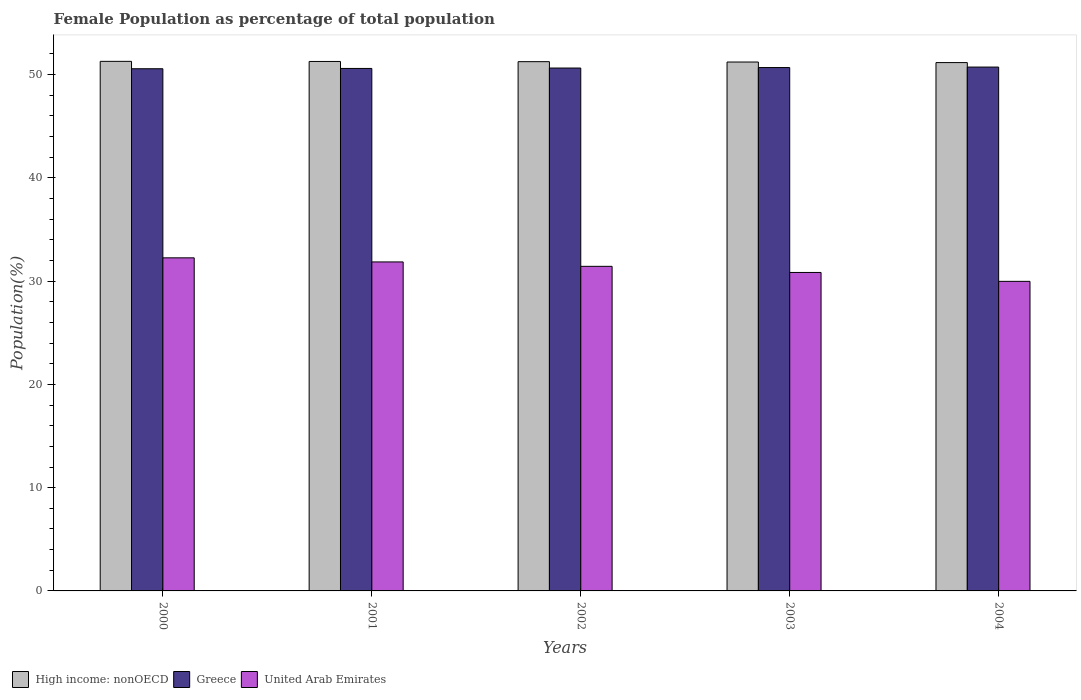Are the number of bars on each tick of the X-axis equal?
Your answer should be very brief. Yes. What is the label of the 4th group of bars from the left?
Ensure brevity in your answer.  2003. What is the female population in in High income: nonOECD in 2002?
Your answer should be very brief. 51.25. Across all years, what is the maximum female population in in United Arab Emirates?
Make the answer very short. 32.26. Across all years, what is the minimum female population in in High income: nonOECD?
Provide a succinct answer. 51.16. In which year was the female population in in High income: nonOECD minimum?
Offer a terse response. 2004. What is the total female population in in High income: nonOECD in the graph?
Your answer should be very brief. 256.2. What is the difference between the female population in in United Arab Emirates in 2000 and that in 2003?
Offer a very short reply. 1.42. What is the difference between the female population in in United Arab Emirates in 2000 and the female population in in High income: nonOECD in 2004?
Your answer should be compact. -18.91. What is the average female population in in High income: nonOECD per year?
Provide a succinct answer. 51.24. In the year 2003, what is the difference between the female population in in Greece and female population in in United Arab Emirates?
Give a very brief answer. 19.84. In how many years, is the female population in in Greece greater than 18 %?
Ensure brevity in your answer.  5. What is the ratio of the female population in in United Arab Emirates in 2000 to that in 2002?
Ensure brevity in your answer.  1.03. Is the difference between the female population in in Greece in 2000 and 2003 greater than the difference between the female population in in United Arab Emirates in 2000 and 2003?
Your answer should be compact. No. What is the difference between the highest and the second highest female population in in Greece?
Make the answer very short. 0.05. What is the difference between the highest and the lowest female population in in United Arab Emirates?
Your answer should be very brief. 2.28. In how many years, is the female population in in United Arab Emirates greater than the average female population in in United Arab Emirates taken over all years?
Ensure brevity in your answer.  3. Is the sum of the female population in in United Arab Emirates in 2000 and 2001 greater than the maximum female population in in Greece across all years?
Ensure brevity in your answer.  Yes. What does the 1st bar from the left in 2002 represents?
Keep it short and to the point. High income: nonOECD. What does the 2nd bar from the right in 2001 represents?
Give a very brief answer. Greece. Is it the case that in every year, the sum of the female population in in United Arab Emirates and female population in in Greece is greater than the female population in in High income: nonOECD?
Provide a short and direct response. Yes. Are all the bars in the graph horizontal?
Ensure brevity in your answer.  No. How many years are there in the graph?
Provide a succinct answer. 5. What is the difference between two consecutive major ticks on the Y-axis?
Give a very brief answer. 10. Does the graph contain any zero values?
Provide a short and direct response. No. Where does the legend appear in the graph?
Keep it short and to the point. Bottom left. How are the legend labels stacked?
Make the answer very short. Horizontal. What is the title of the graph?
Provide a succinct answer. Female Population as percentage of total population. What is the label or title of the Y-axis?
Your response must be concise. Population(%). What is the Population(%) of High income: nonOECD in 2000?
Ensure brevity in your answer.  51.28. What is the Population(%) in Greece in 2000?
Keep it short and to the point. 50.57. What is the Population(%) of United Arab Emirates in 2000?
Ensure brevity in your answer.  32.26. What is the Population(%) in High income: nonOECD in 2001?
Offer a terse response. 51.27. What is the Population(%) of Greece in 2001?
Make the answer very short. 50.6. What is the Population(%) of United Arab Emirates in 2001?
Provide a short and direct response. 31.86. What is the Population(%) of High income: nonOECD in 2002?
Provide a short and direct response. 51.25. What is the Population(%) in Greece in 2002?
Your answer should be compact. 50.64. What is the Population(%) in United Arab Emirates in 2002?
Ensure brevity in your answer.  31.43. What is the Population(%) of High income: nonOECD in 2003?
Your answer should be compact. 51.22. What is the Population(%) of Greece in 2003?
Offer a terse response. 50.68. What is the Population(%) of United Arab Emirates in 2003?
Offer a terse response. 30.84. What is the Population(%) of High income: nonOECD in 2004?
Your answer should be compact. 51.16. What is the Population(%) in Greece in 2004?
Your answer should be very brief. 50.73. What is the Population(%) of United Arab Emirates in 2004?
Your answer should be very brief. 29.98. Across all years, what is the maximum Population(%) of High income: nonOECD?
Provide a succinct answer. 51.28. Across all years, what is the maximum Population(%) of Greece?
Keep it short and to the point. 50.73. Across all years, what is the maximum Population(%) in United Arab Emirates?
Your answer should be compact. 32.26. Across all years, what is the minimum Population(%) in High income: nonOECD?
Offer a terse response. 51.16. Across all years, what is the minimum Population(%) in Greece?
Offer a very short reply. 50.57. Across all years, what is the minimum Population(%) of United Arab Emirates?
Your answer should be compact. 29.98. What is the total Population(%) in High income: nonOECD in the graph?
Keep it short and to the point. 256.2. What is the total Population(%) in Greece in the graph?
Offer a terse response. 253.22. What is the total Population(%) of United Arab Emirates in the graph?
Offer a very short reply. 156.37. What is the difference between the Population(%) in Greece in 2000 and that in 2001?
Provide a short and direct response. -0.03. What is the difference between the Population(%) in United Arab Emirates in 2000 and that in 2001?
Make the answer very short. 0.4. What is the difference between the Population(%) in High income: nonOECD in 2000 and that in 2002?
Give a very brief answer. 0.03. What is the difference between the Population(%) in Greece in 2000 and that in 2002?
Offer a very short reply. -0.07. What is the difference between the Population(%) of United Arab Emirates in 2000 and that in 2002?
Give a very brief answer. 0.82. What is the difference between the Population(%) of High income: nonOECD in 2000 and that in 2003?
Keep it short and to the point. 0.06. What is the difference between the Population(%) in Greece in 2000 and that in 2003?
Give a very brief answer. -0.12. What is the difference between the Population(%) of United Arab Emirates in 2000 and that in 2003?
Give a very brief answer. 1.42. What is the difference between the Population(%) in High income: nonOECD in 2000 and that in 2004?
Give a very brief answer. 0.12. What is the difference between the Population(%) of Greece in 2000 and that in 2004?
Ensure brevity in your answer.  -0.16. What is the difference between the Population(%) of United Arab Emirates in 2000 and that in 2004?
Your response must be concise. 2.28. What is the difference between the Population(%) of High income: nonOECD in 2001 and that in 2002?
Your response must be concise. 0.02. What is the difference between the Population(%) of Greece in 2001 and that in 2002?
Your answer should be very brief. -0.04. What is the difference between the Population(%) of United Arab Emirates in 2001 and that in 2002?
Ensure brevity in your answer.  0.43. What is the difference between the Population(%) in High income: nonOECD in 2001 and that in 2003?
Your response must be concise. 0.05. What is the difference between the Population(%) of Greece in 2001 and that in 2003?
Make the answer very short. -0.09. What is the difference between the Population(%) of United Arab Emirates in 2001 and that in 2003?
Ensure brevity in your answer.  1.02. What is the difference between the Population(%) in High income: nonOECD in 2001 and that in 2004?
Keep it short and to the point. 0.11. What is the difference between the Population(%) in Greece in 2001 and that in 2004?
Ensure brevity in your answer.  -0.13. What is the difference between the Population(%) of United Arab Emirates in 2001 and that in 2004?
Provide a short and direct response. 1.88. What is the difference between the Population(%) of High income: nonOECD in 2002 and that in 2003?
Give a very brief answer. 0.03. What is the difference between the Population(%) in Greece in 2002 and that in 2003?
Ensure brevity in your answer.  -0.05. What is the difference between the Population(%) in United Arab Emirates in 2002 and that in 2003?
Your answer should be compact. 0.59. What is the difference between the Population(%) in High income: nonOECD in 2002 and that in 2004?
Offer a terse response. 0.09. What is the difference between the Population(%) in Greece in 2002 and that in 2004?
Offer a terse response. -0.09. What is the difference between the Population(%) of United Arab Emirates in 2002 and that in 2004?
Your response must be concise. 1.45. What is the difference between the Population(%) of High income: nonOECD in 2003 and that in 2004?
Make the answer very short. 0.06. What is the difference between the Population(%) of Greece in 2003 and that in 2004?
Your response must be concise. -0.05. What is the difference between the Population(%) of United Arab Emirates in 2003 and that in 2004?
Your response must be concise. 0.86. What is the difference between the Population(%) in High income: nonOECD in 2000 and the Population(%) in Greece in 2001?
Your answer should be very brief. 0.69. What is the difference between the Population(%) of High income: nonOECD in 2000 and the Population(%) of United Arab Emirates in 2001?
Give a very brief answer. 19.42. What is the difference between the Population(%) in Greece in 2000 and the Population(%) in United Arab Emirates in 2001?
Ensure brevity in your answer.  18.71. What is the difference between the Population(%) in High income: nonOECD in 2000 and the Population(%) in Greece in 2002?
Keep it short and to the point. 0.65. What is the difference between the Population(%) in High income: nonOECD in 2000 and the Population(%) in United Arab Emirates in 2002?
Ensure brevity in your answer.  19.85. What is the difference between the Population(%) of Greece in 2000 and the Population(%) of United Arab Emirates in 2002?
Make the answer very short. 19.14. What is the difference between the Population(%) in High income: nonOECD in 2000 and the Population(%) in Greece in 2003?
Make the answer very short. 0.6. What is the difference between the Population(%) in High income: nonOECD in 2000 and the Population(%) in United Arab Emirates in 2003?
Your answer should be compact. 20.44. What is the difference between the Population(%) in Greece in 2000 and the Population(%) in United Arab Emirates in 2003?
Offer a terse response. 19.73. What is the difference between the Population(%) of High income: nonOECD in 2000 and the Population(%) of Greece in 2004?
Your response must be concise. 0.55. What is the difference between the Population(%) in High income: nonOECD in 2000 and the Population(%) in United Arab Emirates in 2004?
Your response must be concise. 21.31. What is the difference between the Population(%) of Greece in 2000 and the Population(%) of United Arab Emirates in 2004?
Provide a short and direct response. 20.59. What is the difference between the Population(%) in High income: nonOECD in 2001 and the Population(%) in Greece in 2002?
Ensure brevity in your answer.  0.64. What is the difference between the Population(%) of High income: nonOECD in 2001 and the Population(%) of United Arab Emirates in 2002?
Your answer should be compact. 19.84. What is the difference between the Population(%) of Greece in 2001 and the Population(%) of United Arab Emirates in 2002?
Keep it short and to the point. 19.16. What is the difference between the Population(%) of High income: nonOECD in 2001 and the Population(%) of Greece in 2003?
Ensure brevity in your answer.  0.59. What is the difference between the Population(%) in High income: nonOECD in 2001 and the Population(%) in United Arab Emirates in 2003?
Make the answer very short. 20.43. What is the difference between the Population(%) in Greece in 2001 and the Population(%) in United Arab Emirates in 2003?
Your response must be concise. 19.76. What is the difference between the Population(%) of High income: nonOECD in 2001 and the Population(%) of Greece in 2004?
Your answer should be very brief. 0.54. What is the difference between the Population(%) in High income: nonOECD in 2001 and the Population(%) in United Arab Emirates in 2004?
Your answer should be compact. 21.3. What is the difference between the Population(%) in Greece in 2001 and the Population(%) in United Arab Emirates in 2004?
Offer a very short reply. 20.62. What is the difference between the Population(%) of High income: nonOECD in 2002 and the Population(%) of Greece in 2003?
Offer a very short reply. 0.57. What is the difference between the Population(%) of High income: nonOECD in 2002 and the Population(%) of United Arab Emirates in 2003?
Provide a succinct answer. 20.42. What is the difference between the Population(%) in Greece in 2002 and the Population(%) in United Arab Emirates in 2003?
Offer a very short reply. 19.8. What is the difference between the Population(%) of High income: nonOECD in 2002 and the Population(%) of Greece in 2004?
Provide a short and direct response. 0.52. What is the difference between the Population(%) in High income: nonOECD in 2002 and the Population(%) in United Arab Emirates in 2004?
Give a very brief answer. 21.28. What is the difference between the Population(%) of Greece in 2002 and the Population(%) of United Arab Emirates in 2004?
Ensure brevity in your answer.  20.66. What is the difference between the Population(%) in High income: nonOECD in 2003 and the Population(%) in Greece in 2004?
Offer a very short reply. 0.49. What is the difference between the Population(%) of High income: nonOECD in 2003 and the Population(%) of United Arab Emirates in 2004?
Your answer should be compact. 21.24. What is the difference between the Population(%) of Greece in 2003 and the Population(%) of United Arab Emirates in 2004?
Give a very brief answer. 20.7. What is the average Population(%) in High income: nonOECD per year?
Your response must be concise. 51.24. What is the average Population(%) in Greece per year?
Your answer should be very brief. 50.64. What is the average Population(%) of United Arab Emirates per year?
Give a very brief answer. 31.27. In the year 2000, what is the difference between the Population(%) of High income: nonOECD and Population(%) of Greece?
Ensure brevity in your answer.  0.72. In the year 2000, what is the difference between the Population(%) in High income: nonOECD and Population(%) in United Arab Emirates?
Ensure brevity in your answer.  19.03. In the year 2000, what is the difference between the Population(%) in Greece and Population(%) in United Arab Emirates?
Give a very brief answer. 18.31. In the year 2001, what is the difference between the Population(%) in High income: nonOECD and Population(%) in Greece?
Keep it short and to the point. 0.68. In the year 2001, what is the difference between the Population(%) in High income: nonOECD and Population(%) in United Arab Emirates?
Offer a very short reply. 19.41. In the year 2001, what is the difference between the Population(%) of Greece and Population(%) of United Arab Emirates?
Offer a very short reply. 18.74. In the year 2002, what is the difference between the Population(%) of High income: nonOECD and Population(%) of Greece?
Provide a succinct answer. 0.62. In the year 2002, what is the difference between the Population(%) of High income: nonOECD and Population(%) of United Arab Emirates?
Your response must be concise. 19.82. In the year 2002, what is the difference between the Population(%) in Greece and Population(%) in United Arab Emirates?
Offer a terse response. 19.2. In the year 2003, what is the difference between the Population(%) in High income: nonOECD and Population(%) in Greece?
Offer a very short reply. 0.54. In the year 2003, what is the difference between the Population(%) of High income: nonOECD and Population(%) of United Arab Emirates?
Your response must be concise. 20.38. In the year 2003, what is the difference between the Population(%) of Greece and Population(%) of United Arab Emirates?
Ensure brevity in your answer.  19.84. In the year 2004, what is the difference between the Population(%) in High income: nonOECD and Population(%) in Greece?
Your response must be concise. 0.43. In the year 2004, what is the difference between the Population(%) in High income: nonOECD and Population(%) in United Arab Emirates?
Keep it short and to the point. 21.19. In the year 2004, what is the difference between the Population(%) of Greece and Population(%) of United Arab Emirates?
Your response must be concise. 20.75. What is the ratio of the Population(%) in High income: nonOECD in 2000 to that in 2001?
Ensure brevity in your answer.  1. What is the ratio of the Population(%) in Greece in 2000 to that in 2001?
Your answer should be compact. 1. What is the ratio of the Population(%) in United Arab Emirates in 2000 to that in 2001?
Provide a succinct answer. 1.01. What is the ratio of the Population(%) in Greece in 2000 to that in 2002?
Your answer should be very brief. 1. What is the ratio of the Population(%) in United Arab Emirates in 2000 to that in 2002?
Your response must be concise. 1.03. What is the ratio of the Population(%) in High income: nonOECD in 2000 to that in 2003?
Keep it short and to the point. 1. What is the ratio of the Population(%) in Greece in 2000 to that in 2003?
Offer a very short reply. 1. What is the ratio of the Population(%) of United Arab Emirates in 2000 to that in 2003?
Make the answer very short. 1.05. What is the ratio of the Population(%) of High income: nonOECD in 2000 to that in 2004?
Your response must be concise. 1. What is the ratio of the Population(%) of United Arab Emirates in 2000 to that in 2004?
Give a very brief answer. 1.08. What is the ratio of the Population(%) of High income: nonOECD in 2001 to that in 2002?
Make the answer very short. 1. What is the ratio of the Population(%) in Greece in 2001 to that in 2002?
Ensure brevity in your answer.  1. What is the ratio of the Population(%) of United Arab Emirates in 2001 to that in 2002?
Offer a terse response. 1.01. What is the ratio of the Population(%) of Greece in 2001 to that in 2003?
Give a very brief answer. 1. What is the ratio of the Population(%) in United Arab Emirates in 2001 to that in 2003?
Provide a short and direct response. 1.03. What is the ratio of the Population(%) of High income: nonOECD in 2001 to that in 2004?
Your answer should be very brief. 1. What is the ratio of the Population(%) of Greece in 2001 to that in 2004?
Provide a succinct answer. 1. What is the ratio of the Population(%) in United Arab Emirates in 2001 to that in 2004?
Ensure brevity in your answer.  1.06. What is the ratio of the Population(%) of United Arab Emirates in 2002 to that in 2003?
Offer a terse response. 1.02. What is the ratio of the Population(%) in United Arab Emirates in 2002 to that in 2004?
Provide a succinct answer. 1.05. What is the ratio of the Population(%) of United Arab Emirates in 2003 to that in 2004?
Give a very brief answer. 1.03. What is the difference between the highest and the second highest Population(%) in Greece?
Provide a short and direct response. 0.05. What is the difference between the highest and the second highest Population(%) in United Arab Emirates?
Your response must be concise. 0.4. What is the difference between the highest and the lowest Population(%) in High income: nonOECD?
Make the answer very short. 0.12. What is the difference between the highest and the lowest Population(%) of Greece?
Ensure brevity in your answer.  0.16. What is the difference between the highest and the lowest Population(%) of United Arab Emirates?
Your response must be concise. 2.28. 